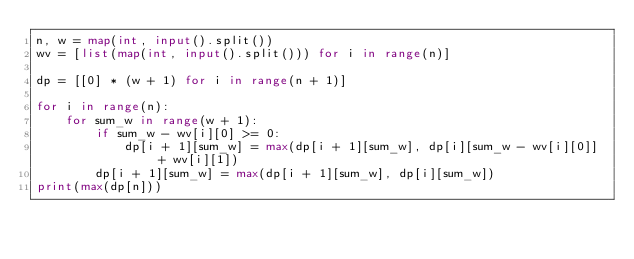<code> <loc_0><loc_0><loc_500><loc_500><_Python_>n, w = map(int, input().split())
wv = [list(map(int, input().split())) for i in range(n)]

dp = [[0] * (w + 1) for i in range(n + 1)]

for i in range(n):
    for sum_w in range(w + 1):
        if sum_w - wv[i][0] >= 0:
            dp[i + 1][sum_w] = max(dp[i + 1][sum_w], dp[i][sum_w - wv[i][0]] + wv[i][1])
        dp[i + 1][sum_w] = max(dp[i + 1][sum_w], dp[i][sum_w])
print(max(dp[n]))</code> 